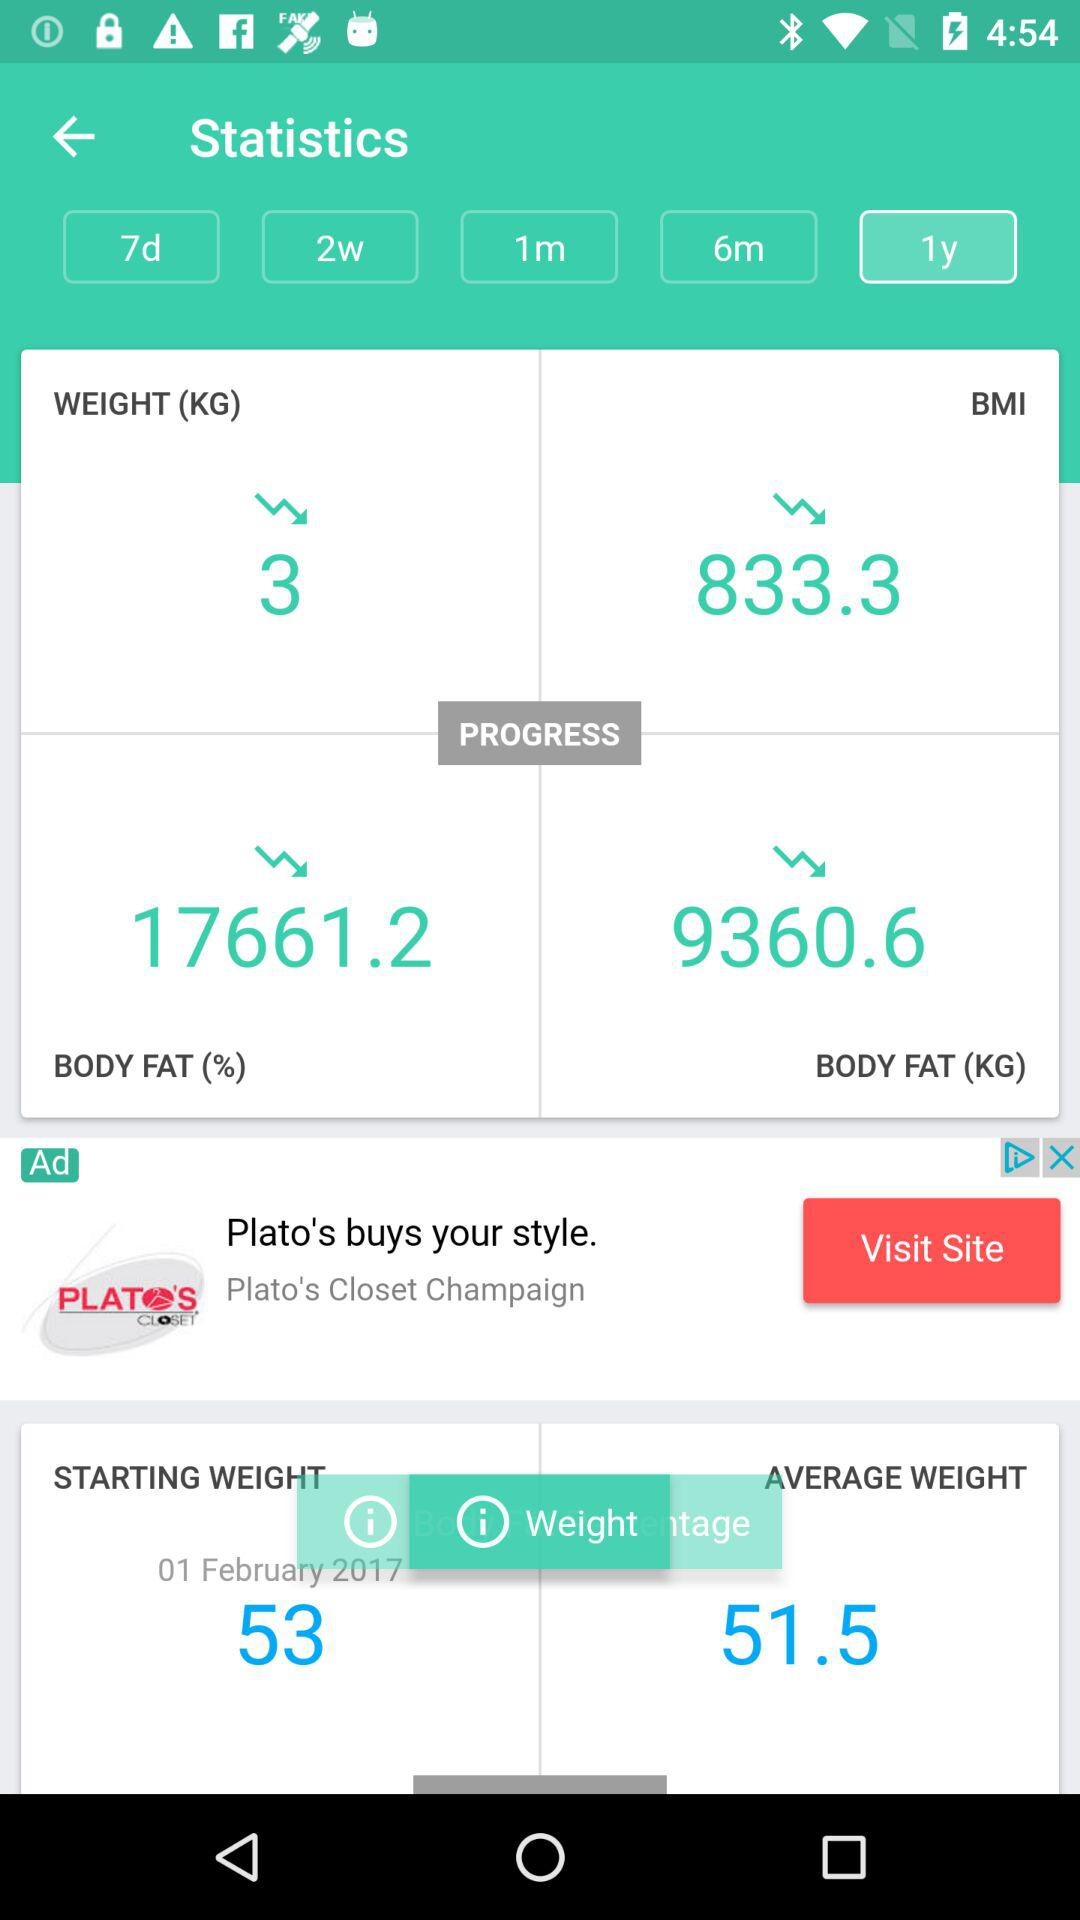What is the starting date?
When the provided information is insufficient, respond with <no answer>. <no answer> 